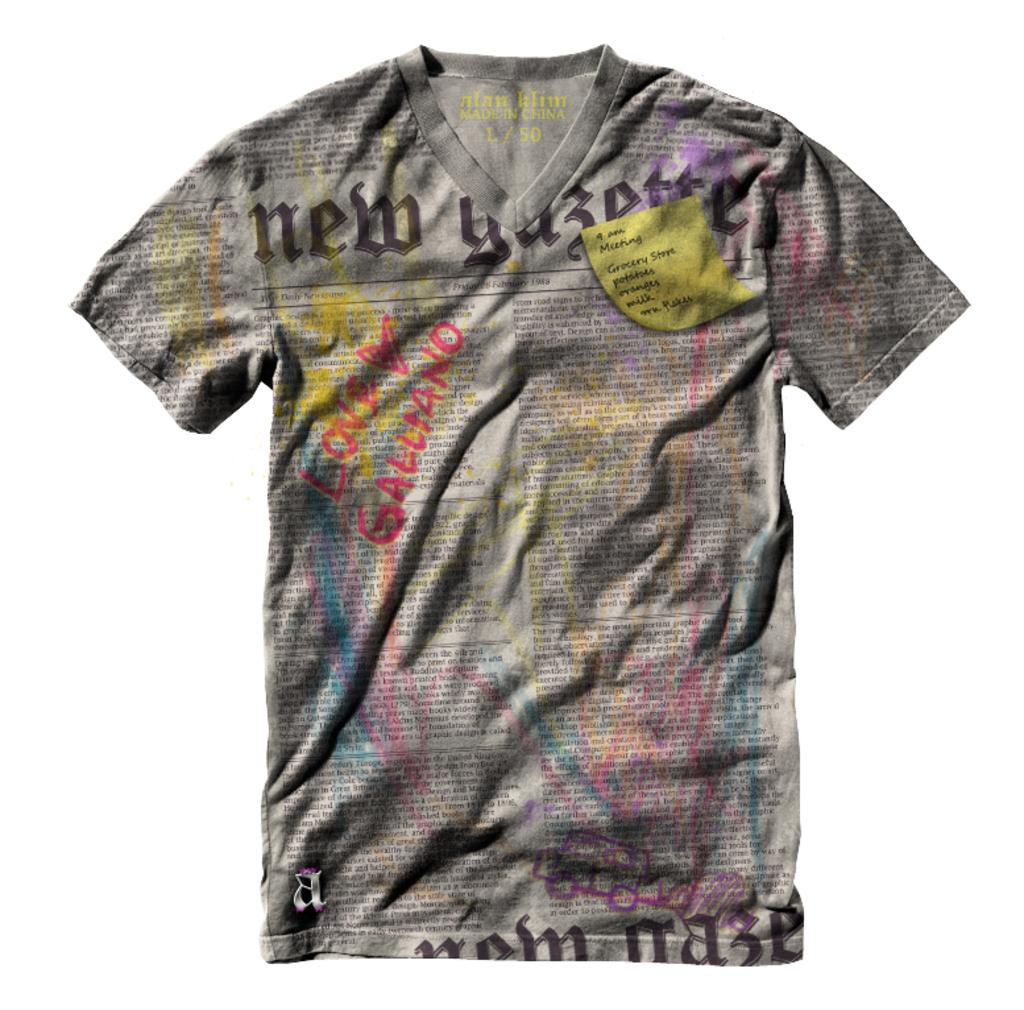What type of clothing item is visible in the image? There is a T-shirt in the image. What is featured on the T-shirt? The T-shirt has a print of words. What is the color of the background in the image? There is a white background in the image. How many railway tracks can be seen in the image? There are no railway tracks present in the image. What type of loss is depicted in the image? There is no loss depicted in the image; it features a T-shirt with a print of words. 